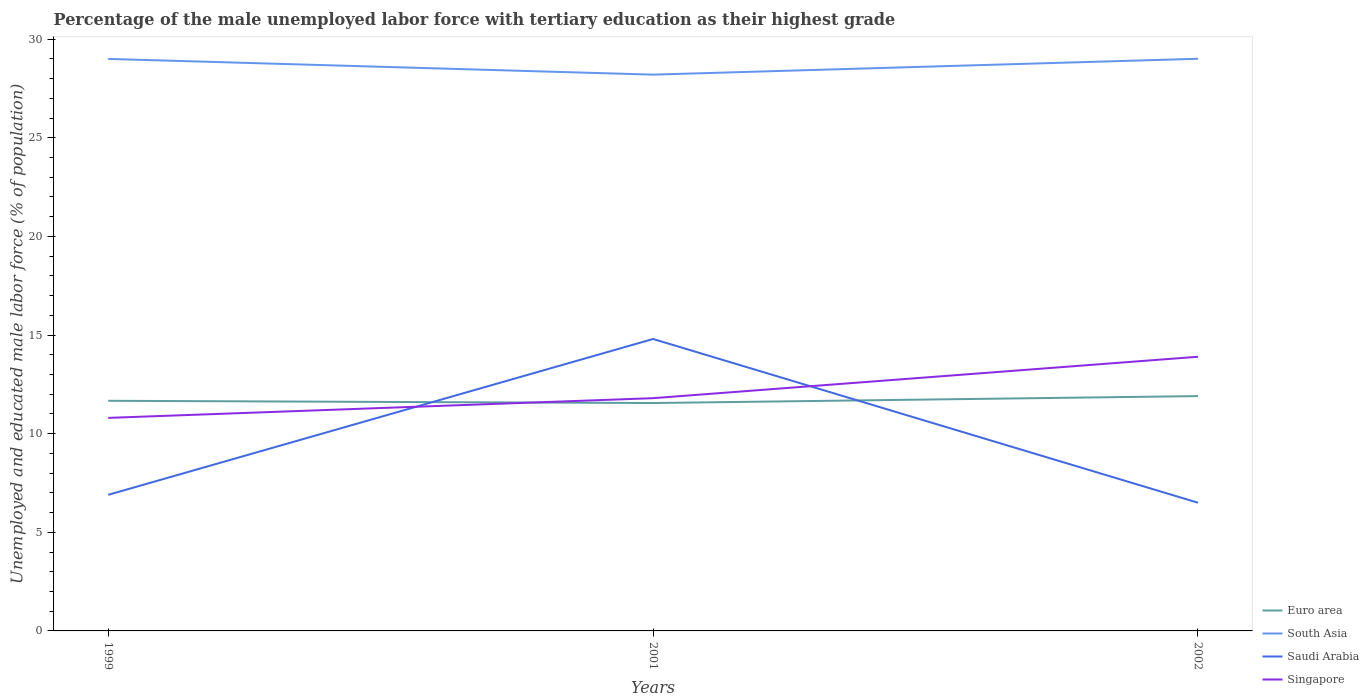Is the number of lines equal to the number of legend labels?
Your answer should be compact. Yes. Across all years, what is the maximum percentage of the unemployed male labor force with tertiary education in Euro area?
Provide a succinct answer. 11.55. What is the total percentage of the unemployed male labor force with tertiary education in Euro area in the graph?
Give a very brief answer. -0.35. What is the difference between the highest and the second highest percentage of the unemployed male labor force with tertiary education in South Asia?
Offer a terse response. 0.8. What is the difference between the highest and the lowest percentage of the unemployed male labor force with tertiary education in South Asia?
Your answer should be compact. 2. Is the percentage of the unemployed male labor force with tertiary education in Singapore strictly greater than the percentage of the unemployed male labor force with tertiary education in Saudi Arabia over the years?
Give a very brief answer. No. How many lines are there?
Your answer should be very brief. 4. How many years are there in the graph?
Offer a very short reply. 3. Are the values on the major ticks of Y-axis written in scientific E-notation?
Your response must be concise. No. Does the graph contain grids?
Give a very brief answer. No. How many legend labels are there?
Give a very brief answer. 4. How are the legend labels stacked?
Provide a short and direct response. Vertical. What is the title of the graph?
Offer a very short reply. Percentage of the male unemployed labor force with tertiary education as their highest grade. Does "East Asia (developing only)" appear as one of the legend labels in the graph?
Your response must be concise. No. What is the label or title of the Y-axis?
Your answer should be very brief. Unemployed and educated male labor force (% of population). What is the Unemployed and educated male labor force (% of population) in Euro area in 1999?
Ensure brevity in your answer.  11.67. What is the Unemployed and educated male labor force (% of population) in South Asia in 1999?
Keep it short and to the point. 29. What is the Unemployed and educated male labor force (% of population) in Saudi Arabia in 1999?
Your answer should be compact. 6.9. What is the Unemployed and educated male labor force (% of population) in Singapore in 1999?
Your response must be concise. 10.8. What is the Unemployed and educated male labor force (% of population) of Euro area in 2001?
Offer a terse response. 11.55. What is the Unemployed and educated male labor force (% of population) in South Asia in 2001?
Your answer should be very brief. 28.2. What is the Unemployed and educated male labor force (% of population) in Saudi Arabia in 2001?
Give a very brief answer. 14.8. What is the Unemployed and educated male labor force (% of population) in Singapore in 2001?
Your answer should be compact. 11.8. What is the Unemployed and educated male labor force (% of population) in Euro area in 2002?
Ensure brevity in your answer.  11.9. What is the Unemployed and educated male labor force (% of population) in South Asia in 2002?
Offer a terse response. 29.01. What is the Unemployed and educated male labor force (% of population) in Saudi Arabia in 2002?
Provide a short and direct response. 6.5. What is the Unemployed and educated male labor force (% of population) of Singapore in 2002?
Offer a terse response. 13.9. Across all years, what is the maximum Unemployed and educated male labor force (% of population) of Euro area?
Keep it short and to the point. 11.9. Across all years, what is the maximum Unemployed and educated male labor force (% of population) of South Asia?
Your response must be concise. 29.01. Across all years, what is the maximum Unemployed and educated male labor force (% of population) in Saudi Arabia?
Offer a terse response. 14.8. Across all years, what is the maximum Unemployed and educated male labor force (% of population) of Singapore?
Your answer should be very brief. 13.9. Across all years, what is the minimum Unemployed and educated male labor force (% of population) in Euro area?
Your answer should be very brief. 11.55. Across all years, what is the minimum Unemployed and educated male labor force (% of population) in South Asia?
Your answer should be compact. 28.2. Across all years, what is the minimum Unemployed and educated male labor force (% of population) of Singapore?
Your response must be concise. 10.8. What is the total Unemployed and educated male labor force (% of population) in Euro area in the graph?
Ensure brevity in your answer.  35.13. What is the total Unemployed and educated male labor force (% of population) of South Asia in the graph?
Offer a terse response. 86.21. What is the total Unemployed and educated male labor force (% of population) in Saudi Arabia in the graph?
Give a very brief answer. 28.2. What is the total Unemployed and educated male labor force (% of population) in Singapore in the graph?
Make the answer very short. 36.5. What is the difference between the Unemployed and educated male labor force (% of population) in Euro area in 1999 and that in 2001?
Give a very brief answer. 0.11. What is the difference between the Unemployed and educated male labor force (% of population) of South Asia in 1999 and that in 2001?
Provide a short and direct response. 0.8. What is the difference between the Unemployed and educated male labor force (% of population) of Saudi Arabia in 1999 and that in 2001?
Keep it short and to the point. -7.9. What is the difference between the Unemployed and educated male labor force (% of population) of Singapore in 1999 and that in 2001?
Ensure brevity in your answer.  -1. What is the difference between the Unemployed and educated male labor force (% of population) of Euro area in 1999 and that in 2002?
Ensure brevity in your answer.  -0.24. What is the difference between the Unemployed and educated male labor force (% of population) of South Asia in 1999 and that in 2002?
Keep it short and to the point. -0.01. What is the difference between the Unemployed and educated male labor force (% of population) of Singapore in 1999 and that in 2002?
Give a very brief answer. -3.1. What is the difference between the Unemployed and educated male labor force (% of population) of Euro area in 2001 and that in 2002?
Keep it short and to the point. -0.35. What is the difference between the Unemployed and educated male labor force (% of population) of South Asia in 2001 and that in 2002?
Make the answer very short. -0.8. What is the difference between the Unemployed and educated male labor force (% of population) of Singapore in 2001 and that in 2002?
Offer a terse response. -2.1. What is the difference between the Unemployed and educated male labor force (% of population) of Euro area in 1999 and the Unemployed and educated male labor force (% of population) of South Asia in 2001?
Provide a succinct answer. -16.53. What is the difference between the Unemployed and educated male labor force (% of population) of Euro area in 1999 and the Unemployed and educated male labor force (% of population) of Saudi Arabia in 2001?
Provide a succinct answer. -3.13. What is the difference between the Unemployed and educated male labor force (% of population) of Euro area in 1999 and the Unemployed and educated male labor force (% of population) of Singapore in 2001?
Give a very brief answer. -0.13. What is the difference between the Unemployed and educated male labor force (% of population) of Euro area in 1999 and the Unemployed and educated male labor force (% of population) of South Asia in 2002?
Offer a terse response. -17.34. What is the difference between the Unemployed and educated male labor force (% of population) of Euro area in 1999 and the Unemployed and educated male labor force (% of population) of Saudi Arabia in 2002?
Give a very brief answer. 5.17. What is the difference between the Unemployed and educated male labor force (% of population) of Euro area in 1999 and the Unemployed and educated male labor force (% of population) of Singapore in 2002?
Provide a short and direct response. -2.23. What is the difference between the Unemployed and educated male labor force (% of population) in Euro area in 2001 and the Unemployed and educated male labor force (% of population) in South Asia in 2002?
Offer a terse response. -17.45. What is the difference between the Unemployed and educated male labor force (% of population) in Euro area in 2001 and the Unemployed and educated male labor force (% of population) in Saudi Arabia in 2002?
Your response must be concise. 5.05. What is the difference between the Unemployed and educated male labor force (% of population) of Euro area in 2001 and the Unemployed and educated male labor force (% of population) of Singapore in 2002?
Offer a terse response. -2.35. What is the difference between the Unemployed and educated male labor force (% of population) of South Asia in 2001 and the Unemployed and educated male labor force (% of population) of Saudi Arabia in 2002?
Make the answer very short. 21.7. What is the difference between the Unemployed and educated male labor force (% of population) of South Asia in 2001 and the Unemployed and educated male labor force (% of population) of Singapore in 2002?
Provide a succinct answer. 14.3. What is the difference between the Unemployed and educated male labor force (% of population) of Saudi Arabia in 2001 and the Unemployed and educated male labor force (% of population) of Singapore in 2002?
Make the answer very short. 0.9. What is the average Unemployed and educated male labor force (% of population) in Euro area per year?
Provide a succinct answer. 11.71. What is the average Unemployed and educated male labor force (% of population) in South Asia per year?
Provide a short and direct response. 28.74. What is the average Unemployed and educated male labor force (% of population) of Saudi Arabia per year?
Ensure brevity in your answer.  9.4. What is the average Unemployed and educated male labor force (% of population) of Singapore per year?
Your answer should be very brief. 12.17. In the year 1999, what is the difference between the Unemployed and educated male labor force (% of population) of Euro area and Unemployed and educated male labor force (% of population) of South Asia?
Make the answer very short. -17.33. In the year 1999, what is the difference between the Unemployed and educated male labor force (% of population) in Euro area and Unemployed and educated male labor force (% of population) in Saudi Arabia?
Give a very brief answer. 4.77. In the year 1999, what is the difference between the Unemployed and educated male labor force (% of population) in Euro area and Unemployed and educated male labor force (% of population) in Singapore?
Give a very brief answer. 0.87. In the year 1999, what is the difference between the Unemployed and educated male labor force (% of population) in South Asia and Unemployed and educated male labor force (% of population) in Saudi Arabia?
Ensure brevity in your answer.  22.1. In the year 1999, what is the difference between the Unemployed and educated male labor force (% of population) of South Asia and Unemployed and educated male labor force (% of population) of Singapore?
Give a very brief answer. 18.2. In the year 2001, what is the difference between the Unemployed and educated male labor force (% of population) of Euro area and Unemployed and educated male labor force (% of population) of South Asia?
Your answer should be very brief. -16.65. In the year 2001, what is the difference between the Unemployed and educated male labor force (% of population) of Euro area and Unemployed and educated male labor force (% of population) of Saudi Arabia?
Offer a very short reply. -3.25. In the year 2001, what is the difference between the Unemployed and educated male labor force (% of population) in Euro area and Unemployed and educated male labor force (% of population) in Singapore?
Make the answer very short. -0.25. In the year 2001, what is the difference between the Unemployed and educated male labor force (% of population) in South Asia and Unemployed and educated male labor force (% of population) in Saudi Arabia?
Provide a succinct answer. 13.4. In the year 2001, what is the difference between the Unemployed and educated male labor force (% of population) in South Asia and Unemployed and educated male labor force (% of population) in Singapore?
Offer a terse response. 16.4. In the year 2001, what is the difference between the Unemployed and educated male labor force (% of population) of Saudi Arabia and Unemployed and educated male labor force (% of population) of Singapore?
Keep it short and to the point. 3. In the year 2002, what is the difference between the Unemployed and educated male labor force (% of population) of Euro area and Unemployed and educated male labor force (% of population) of South Asia?
Provide a succinct answer. -17.1. In the year 2002, what is the difference between the Unemployed and educated male labor force (% of population) of Euro area and Unemployed and educated male labor force (% of population) of Saudi Arabia?
Ensure brevity in your answer.  5.41. In the year 2002, what is the difference between the Unemployed and educated male labor force (% of population) of Euro area and Unemployed and educated male labor force (% of population) of Singapore?
Offer a very short reply. -2. In the year 2002, what is the difference between the Unemployed and educated male labor force (% of population) of South Asia and Unemployed and educated male labor force (% of population) of Saudi Arabia?
Provide a succinct answer. 22.51. In the year 2002, what is the difference between the Unemployed and educated male labor force (% of population) of South Asia and Unemployed and educated male labor force (% of population) of Singapore?
Offer a very short reply. 15.11. What is the ratio of the Unemployed and educated male labor force (% of population) in Euro area in 1999 to that in 2001?
Give a very brief answer. 1.01. What is the ratio of the Unemployed and educated male labor force (% of population) in South Asia in 1999 to that in 2001?
Your answer should be compact. 1.03. What is the ratio of the Unemployed and educated male labor force (% of population) of Saudi Arabia in 1999 to that in 2001?
Offer a terse response. 0.47. What is the ratio of the Unemployed and educated male labor force (% of population) of Singapore in 1999 to that in 2001?
Give a very brief answer. 0.92. What is the ratio of the Unemployed and educated male labor force (% of population) in Euro area in 1999 to that in 2002?
Your answer should be very brief. 0.98. What is the ratio of the Unemployed and educated male labor force (% of population) in South Asia in 1999 to that in 2002?
Make the answer very short. 1. What is the ratio of the Unemployed and educated male labor force (% of population) of Saudi Arabia in 1999 to that in 2002?
Provide a short and direct response. 1.06. What is the ratio of the Unemployed and educated male labor force (% of population) of Singapore in 1999 to that in 2002?
Provide a short and direct response. 0.78. What is the ratio of the Unemployed and educated male labor force (% of population) of Euro area in 2001 to that in 2002?
Make the answer very short. 0.97. What is the ratio of the Unemployed and educated male labor force (% of population) in South Asia in 2001 to that in 2002?
Provide a short and direct response. 0.97. What is the ratio of the Unemployed and educated male labor force (% of population) in Saudi Arabia in 2001 to that in 2002?
Provide a succinct answer. 2.28. What is the ratio of the Unemployed and educated male labor force (% of population) in Singapore in 2001 to that in 2002?
Ensure brevity in your answer.  0.85. What is the difference between the highest and the second highest Unemployed and educated male labor force (% of population) of Euro area?
Keep it short and to the point. 0.24. What is the difference between the highest and the second highest Unemployed and educated male labor force (% of population) of South Asia?
Your response must be concise. 0.01. What is the difference between the highest and the second highest Unemployed and educated male labor force (% of population) in Saudi Arabia?
Your answer should be compact. 7.9. What is the difference between the highest and the second highest Unemployed and educated male labor force (% of population) in Singapore?
Provide a succinct answer. 2.1. What is the difference between the highest and the lowest Unemployed and educated male labor force (% of population) of Euro area?
Provide a succinct answer. 0.35. What is the difference between the highest and the lowest Unemployed and educated male labor force (% of population) of South Asia?
Offer a terse response. 0.8. What is the difference between the highest and the lowest Unemployed and educated male labor force (% of population) in Saudi Arabia?
Ensure brevity in your answer.  8.3. 